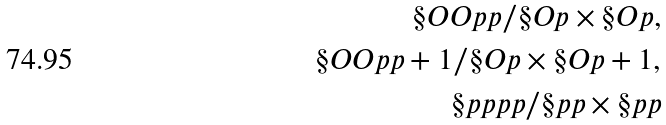<formula> <loc_0><loc_0><loc_500><loc_500>\S O O { p } { p } / \S O p \times \S O p , \\ \S O O { p } { p + 1 } / \S O p \times \S O { p + 1 } , \\ \S p p { p } { p } / \S p p \times \S p p</formula> 